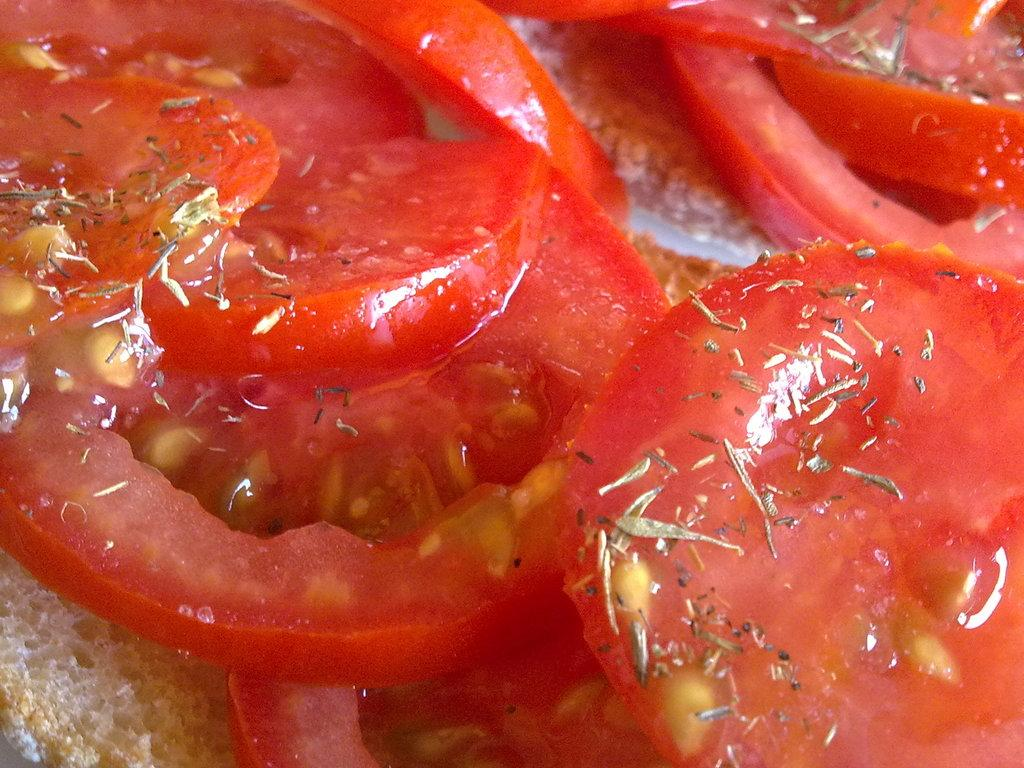What is visible in the image? There is some food visible in the image. Where did the food come from during the mother's trip to the dock? There is no information about a trip, a mother, or a dock in the image or the provided facts. 